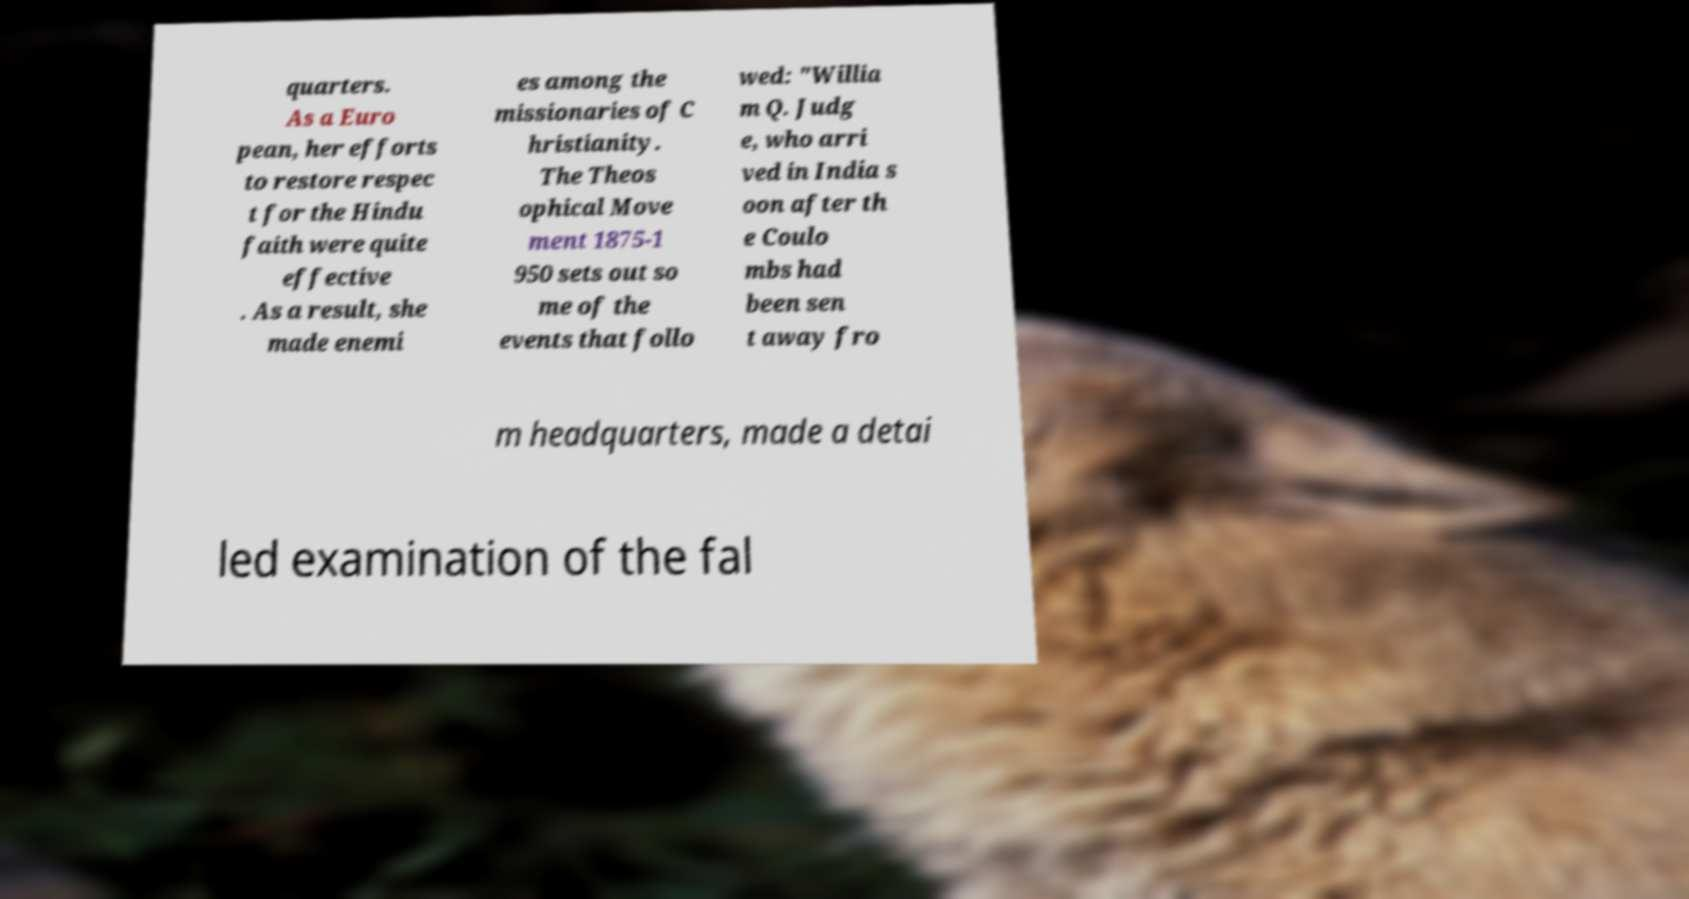Could you extract and type out the text from this image? quarters. As a Euro pean, her efforts to restore respec t for the Hindu faith were quite effective . As a result, she made enemi es among the missionaries of C hristianity. The Theos ophical Move ment 1875-1 950 sets out so me of the events that follo wed: "Willia m Q. Judg e, who arri ved in India s oon after th e Coulo mbs had been sen t away fro m headquarters, made a detai led examination of the fal 